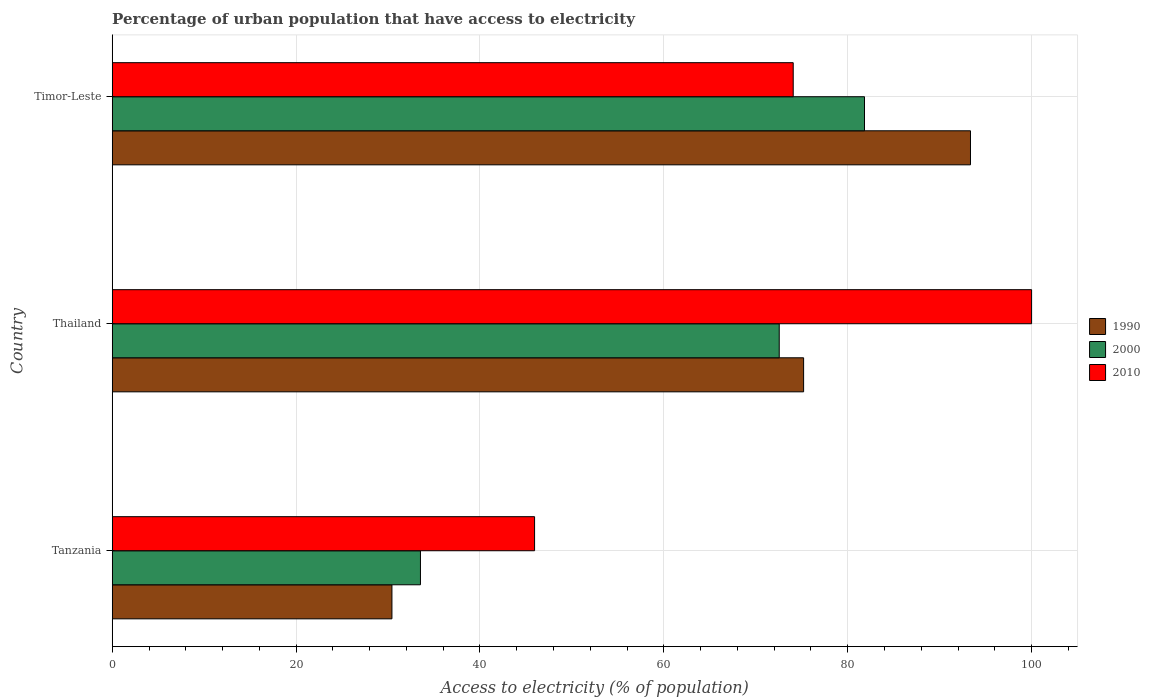How many different coloured bars are there?
Your answer should be very brief. 3. How many bars are there on the 3rd tick from the bottom?
Keep it short and to the point. 3. What is the label of the 1st group of bars from the top?
Make the answer very short. Timor-Leste. Across all countries, what is the maximum percentage of urban population that have access to electricity in 2000?
Make the answer very short. 81.83. Across all countries, what is the minimum percentage of urban population that have access to electricity in 1990?
Your answer should be very brief. 30.43. In which country was the percentage of urban population that have access to electricity in 1990 maximum?
Provide a succinct answer. Timor-Leste. In which country was the percentage of urban population that have access to electricity in 1990 minimum?
Provide a succinct answer. Tanzania. What is the total percentage of urban population that have access to electricity in 2000 in the graph?
Provide a succinct answer. 187.9. What is the difference between the percentage of urban population that have access to electricity in 1990 in Tanzania and that in Timor-Leste?
Make the answer very short. -62.93. What is the difference between the percentage of urban population that have access to electricity in 2000 in Thailand and the percentage of urban population that have access to electricity in 2010 in Timor-Leste?
Ensure brevity in your answer.  -1.52. What is the average percentage of urban population that have access to electricity in 1990 per country?
Offer a very short reply. 66.33. What is the difference between the percentage of urban population that have access to electricity in 1990 and percentage of urban population that have access to electricity in 2000 in Thailand?
Keep it short and to the point. 2.65. What is the ratio of the percentage of urban population that have access to electricity in 1990 in Tanzania to that in Timor-Leste?
Your response must be concise. 0.33. Is the difference between the percentage of urban population that have access to electricity in 1990 in Thailand and Timor-Leste greater than the difference between the percentage of urban population that have access to electricity in 2000 in Thailand and Timor-Leste?
Offer a terse response. No. What is the difference between the highest and the second highest percentage of urban population that have access to electricity in 2010?
Ensure brevity in your answer.  25.93. What is the difference between the highest and the lowest percentage of urban population that have access to electricity in 2000?
Your answer should be very brief. 48.3. What does the 2nd bar from the top in Tanzania represents?
Your answer should be compact. 2000. What does the 2nd bar from the bottom in Timor-Leste represents?
Provide a succinct answer. 2000. How many bars are there?
Ensure brevity in your answer.  9. How many countries are there in the graph?
Offer a terse response. 3. What is the difference between two consecutive major ticks on the X-axis?
Ensure brevity in your answer.  20. Are the values on the major ticks of X-axis written in scientific E-notation?
Offer a very short reply. No. Does the graph contain any zero values?
Your answer should be compact. No. How many legend labels are there?
Give a very brief answer. 3. How are the legend labels stacked?
Your answer should be compact. Vertical. What is the title of the graph?
Offer a very short reply. Percentage of urban population that have access to electricity. What is the label or title of the X-axis?
Provide a succinct answer. Access to electricity (% of population). What is the Access to electricity (% of population) of 1990 in Tanzania?
Offer a terse response. 30.43. What is the Access to electricity (% of population) in 2000 in Tanzania?
Provide a succinct answer. 33.53. What is the Access to electricity (% of population) in 2010 in Tanzania?
Offer a terse response. 45.94. What is the Access to electricity (% of population) of 1990 in Thailand?
Give a very brief answer. 75.2. What is the Access to electricity (% of population) in 2000 in Thailand?
Keep it short and to the point. 72.55. What is the Access to electricity (% of population) in 1990 in Timor-Leste?
Make the answer very short. 93.35. What is the Access to electricity (% of population) of 2000 in Timor-Leste?
Provide a succinct answer. 81.83. What is the Access to electricity (% of population) in 2010 in Timor-Leste?
Offer a very short reply. 74.07. Across all countries, what is the maximum Access to electricity (% of population) in 1990?
Give a very brief answer. 93.35. Across all countries, what is the maximum Access to electricity (% of population) of 2000?
Offer a very short reply. 81.83. Across all countries, what is the maximum Access to electricity (% of population) in 2010?
Ensure brevity in your answer.  100. Across all countries, what is the minimum Access to electricity (% of population) in 1990?
Provide a short and direct response. 30.43. Across all countries, what is the minimum Access to electricity (% of population) in 2000?
Your response must be concise. 33.53. Across all countries, what is the minimum Access to electricity (% of population) of 2010?
Offer a terse response. 45.94. What is the total Access to electricity (% of population) of 1990 in the graph?
Provide a succinct answer. 198.98. What is the total Access to electricity (% of population) in 2000 in the graph?
Provide a short and direct response. 187.9. What is the total Access to electricity (% of population) of 2010 in the graph?
Give a very brief answer. 220.01. What is the difference between the Access to electricity (% of population) of 1990 in Tanzania and that in Thailand?
Offer a very short reply. -44.78. What is the difference between the Access to electricity (% of population) in 2000 in Tanzania and that in Thailand?
Make the answer very short. -39.02. What is the difference between the Access to electricity (% of population) in 2010 in Tanzania and that in Thailand?
Your response must be concise. -54.06. What is the difference between the Access to electricity (% of population) in 1990 in Tanzania and that in Timor-Leste?
Ensure brevity in your answer.  -62.93. What is the difference between the Access to electricity (% of population) in 2000 in Tanzania and that in Timor-Leste?
Make the answer very short. -48.3. What is the difference between the Access to electricity (% of population) in 2010 in Tanzania and that in Timor-Leste?
Your answer should be very brief. -28.13. What is the difference between the Access to electricity (% of population) in 1990 in Thailand and that in Timor-Leste?
Ensure brevity in your answer.  -18.15. What is the difference between the Access to electricity (% of population) of 2000 in Thailand and that in Timor-Leste?
Offer a terse response. -9.27. What is the difference between the Access to electricity (% of population) in 2010 in Thailand and that in Timor-Leste?
Your response must be concise. 25.93. What is the difference between the Access to electricity (% of population) of 1990 in Tanzania and the Access to electricity (% of population) of 2000 in Thailand?
Your answer should be very brief. -42.13. What is the difference between the Access to electricity (% of population) of 1990 in Tanzania and the Access to electricity (% of population) of 2010 in Thailand?
Your answer should be very brief. -69.57. What is the difference between the Access to electricity (% of population) in 2000 in Tanzania and the Access to electricity (% of population) in 2010 in Thailand?
Make the answer very short. -66.47. What is the difference between the Access to electricity (% of population) in 1990 in Tanzania and the Access to electricity (% of population) in 2000 in Timor-Leste?
Offer a very short reply. -51.4. What is the difference between the Access to electricity (% of population) in 1990 in Tanzania and the Access to electricity (% of population) in 2010 in Timor-Leste?
Your answer should be compact. -43.65. What is the difference between the Access to electricity (% of population) in 2000 in Tanzania and the Access to electricity (% of population) in 2010 in Timor-Leste?
Make the answer very short. -40.55. What is the difference between the Access to electricity (% of population) of 1990 in Thailand and the Access to electricity (% of population) of 2000 in Timor-Leste?
Your response must be concise. -6.62. What is the difference between the Access to electricity (% of population) in 1990 in Thailand and the Access to electricity (% of population) in 2010 in Timor-Leste?
Keep it short and to the point. 1.13. What is the difference between the Access to electricity (% of population) in 2000 in Thailand and the Access to electricity (% of population) in 2010 in Timor-Leste?
Provide a succinct answer. -1.52. What is the average Access to electricity (% of population) in 1990 per country?
Your answer should be very brief. 66.33. What is the average Access to electricity (% of population) in 2000 per country?
Offer a very short reply. 62.63. What is the average Access to electricity (% of population) of 2010 per country?
Provide a succinct answer. 73.34. What is the difference between the Access to electricity (% of population) of 1990 and Access to electricity (% of population) of 2000 in Tanzania?
Provide a short and direct response. -3.1. What is the difference between the Access to electricity (% of population) of 1990 and Access to electricity (% of population) of 2010 in Tanzania?
Provide a short and direct response. -15.51. What is the difference between the Access to electricity (% of population) in 2000 and Access to electricity (% of population) in 2010 in Tanzania?
Your answer should be very brief. -12.41. What is the difference between the Access to electricity (% of population) of 1990 and Access to electricity (% of population) of 2000 in Thailand?
Provide a succinct answer. 2.65. What is the difference between the Access to electricity (% of population) in 1990 and Access to electricity (% of population) in 2010 in Thailand?
Ensure brevity in your answer.  -24.8. What is the difference between the Access to electricity (% of population) of 2000 and Access to electricity (% of population) of 2010 in Thailand?
Offer a very short reply. -27.45. What is the difference between the Access to electricity (% of population) in 1990 and Access to electricity (% of population) in 2000 in Timor-Leste?
Your answer should be compact. 11.53. What is the difference between the Access to electricity (% of population) of 1990 and Access to electricity (% of population) of 2010 in Timor-Leste?
Provide a succinct answer. 19.28. What is the difference between the Access to electricity (% of population) in 2000 and Access to electricity (% of population) in 2010 in Timor-Leste?
Give a very brief answer. 7.75. What is the ratio of the Access to electricity (% of population) of 1990 in Tanzania to that in Thailand?
Ensure brevity in your answer.  0.4. What is the ratio of the Access to electricity (% of population) in 2000 in Tanzania to that in Thailand?
Give a very brief answer. 0.46. What is the ratio of the Access to electricity (% of population) in 2010 in Tanzania to that in Thailand?
Offer a terse response. 0.46. What is the ratio of the Access to electricity (% of population) in 1990 in Tanzania to that in Timor-Leste?
Provide a succinct answer. 0.33. What is the ratio of the Access to electricity (% of population) in 2000 in Tanzania to that in Timor-Leste?
Ensure brevity in your answer.  0.41. What is the ratio of the Access to electricity (% of population) of 2010 in Tanzania to that in Timor-Leste?
Your answer should be very brief. 0.62. What is the ratio of the Access to electricity (% of population) in 1990 in Thailand to that in Timor-Leste?
Ensure brevity in your answer.  0.81. What is the ratio of the Access to electricity (% of population) of 2000 in Thailand to that in Timor-Leste?
Offer a very short reply. 0.89. What is the ratio of the Access to electricity (% of population) of 2010 in Thailand to that in Timor-Leste?
Your answer should be very brief. 1.35. What is the difference between the highest and the second highest Access to electricity (% of population) of 1990?
Your answer should be compact. 18.15. What is the difference between the highest and the second highest Access to electricity (% of population) of 2000?
Your answer should be compact. 9.27. What is the difference between the highest and the second highest Access to electricity (% of population) in 2010?
Keep it short and to the point. 25.93. What is the difference between the highest and the lowest Access to electricity (% of population) of 1990?
Provide a succinct answer. 62.93. What is the difference between the highest and the lowest Access to electricity (% of population) of 2000?
Offer a terse response. 48.3. What is the difference between the highest and the lowest Access to electricity (% of population) in 2010?
Provide a short and direct response. 54.06. 